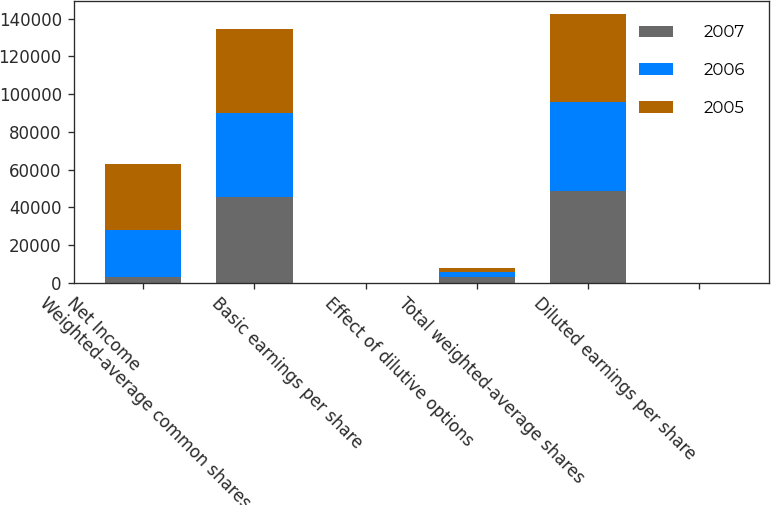Convert chart. <chart><loc_0><loc_0><loc_500><loc_500><stacked_bar_chart><ecel><fcel>Net Income<fcel>Weighted-average common shares<fcel>Basic earnings per share<fcel>Effect of dilutive options<fcel>Total weighted-average shares<fcel>Diluted earnings per share<nl><fcel>2007<fcel>2912<fcel>45630<fcel>1.94<fcel>2912<fcel>48542<fcel>1.83<nl><fcel>2006<fcel>25117<fcel>44415<fcel>0.57<fcel>2766<fcel>47181<fcel>0.53<nl><fcel>2005<fcel>34687<fcel>44202<fcel>0.78<fcel>2342<fcel>46544<fcel>0.75<nl></chart> 